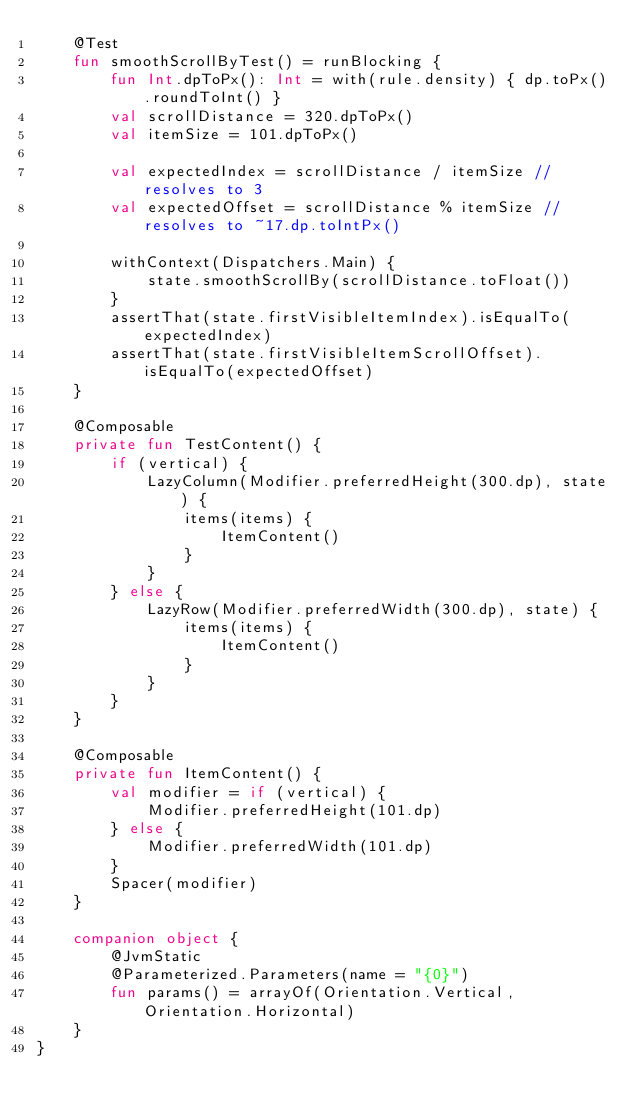<code> <loc_0><loc_0><loc_500><loc_500><_Kotlin_>    @Test
    fun smoothScrollByTest() = runBlocking {
        fun Int.dpToPx(): Int = with(rule.density) { dp.toPx().roundToInt() }
        val scrollDistance = 320.dpToPx()
        val itemSize = 101.dpToPx()

        val expectedIndex = scrollDistance / itemSize // resolves to 3
        val expectedOffset = scrollDistance % itemSize // resolves to ~17.dp.toIntPx()

        withContext(Dispatchers.Main) {
            state.smoothScrollBy(scrollDistance.toFloat())
        }
        assertThat(state.firstVisibleItemIndex).isEqualTo(expectedIndex)
        assertThat(state.firstVisibleItemScrollOffset).isEqualTo(expectedOffset)
    }

    @Composable
    private fun TestContent() {
        if (vertical) {
            LazyColumn(Modifier.preferredHeight(300.dp), state) {
                items(items) {
                    ItemContent()
                }
            }
        } else {
            LazyRow(Modifier.preferredWidth(300.dp), state) {
                items(items) {
                    ItemContent()
                }
            }
        }
    }

    @Composable
    private fun ItemContent() {
        val modifier = if (vertical) {
            Modifier.preferredHeight(101.dp)
        } else {
            Modifier.preferredWidth(101.dp)
        }
        Spacer(modifier)
    }

    companion object {
        @JvmStatic
        @Parameterized.Parameters(name = "{0}")
        fun params() = arrayOf(Orientation.Vertical, Orientation.Horizontal)
    }
}
</code> 